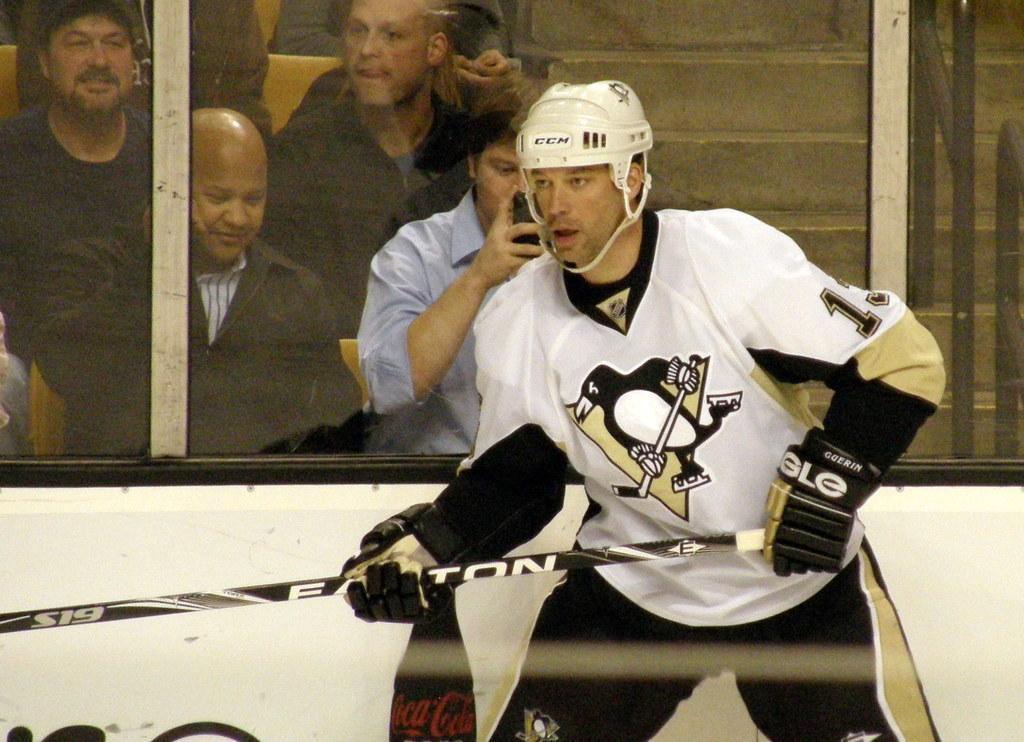What is the man wearing on his head in the image? The man is wearing a helmet in the image. What object is the man holding in his hand? The man is holding a bat in the image. What can be seen through the glass windows in the image? People and steps can be seen through the glass windows in the image. What is the man holding in his other hand? The man is holding a mobile in the image. What type of trade is being conducted through the glass windows in the image? There is no indication of any trade being conducted through the glass windows in the image. What is the aftermath of the event that took place in the image? There is no event or aftermath depicted in the image; it simply shows a man holding a bat and a mobile, with people and steps visible through glass windows. 